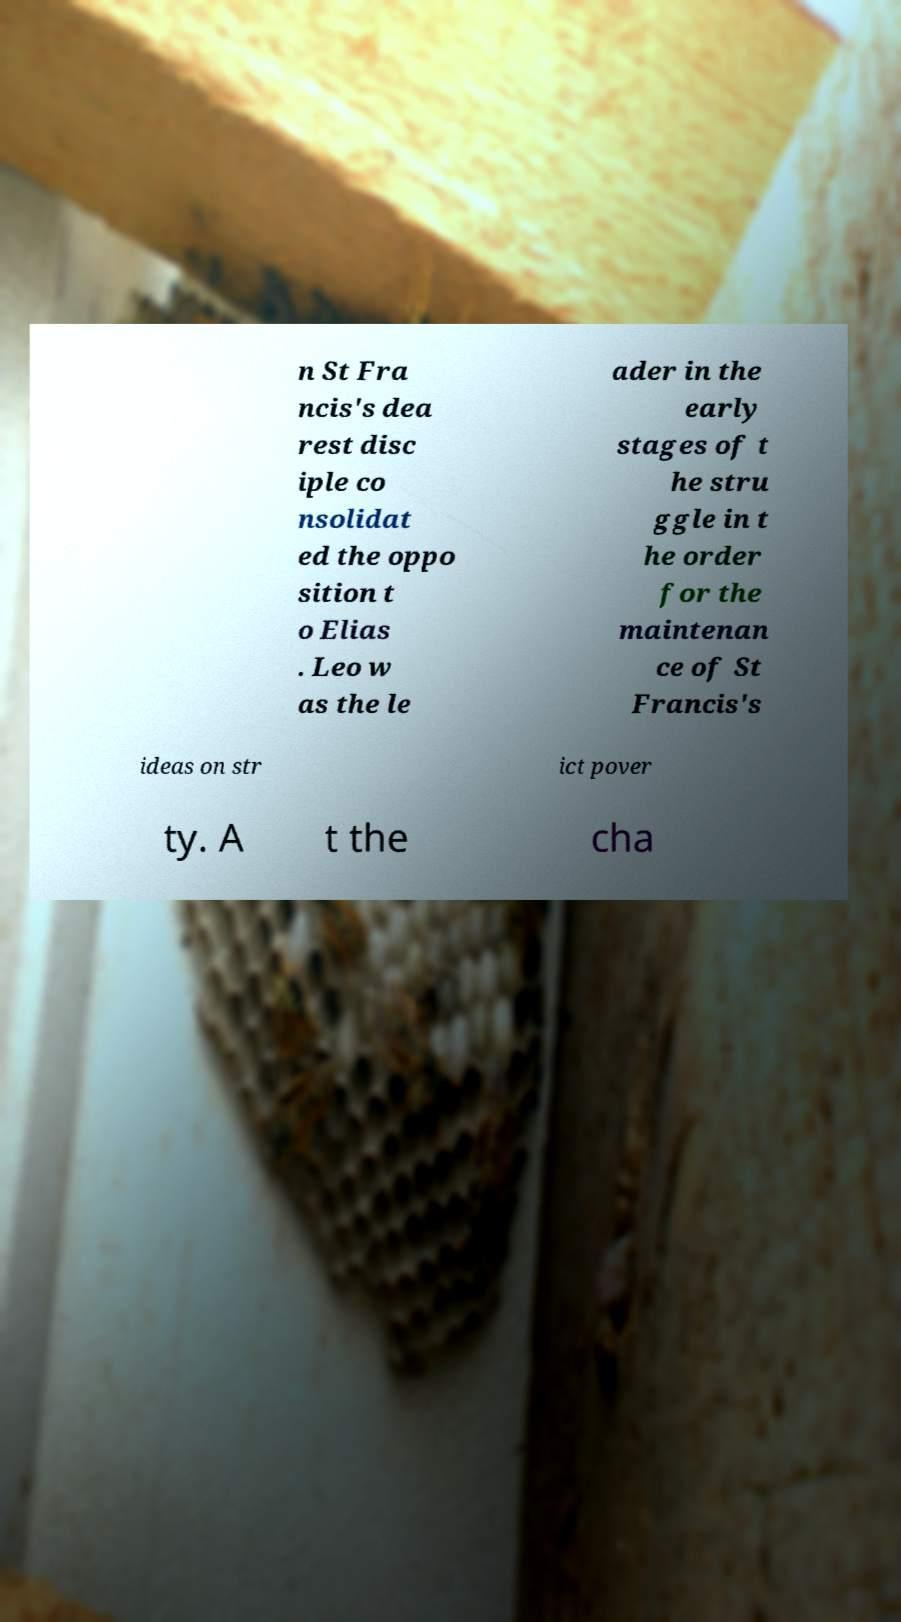Please read and relay the text visible in this image. What does it say? n St Fra ncis's dea rest disc iple co nsolidat ed the oppo sition t o Elias . Leo w as the le ader in the early stages of t he stru ggle in t he order for the maintenan ce of St Francis's ideas on str ict pover ty. A t the cha 